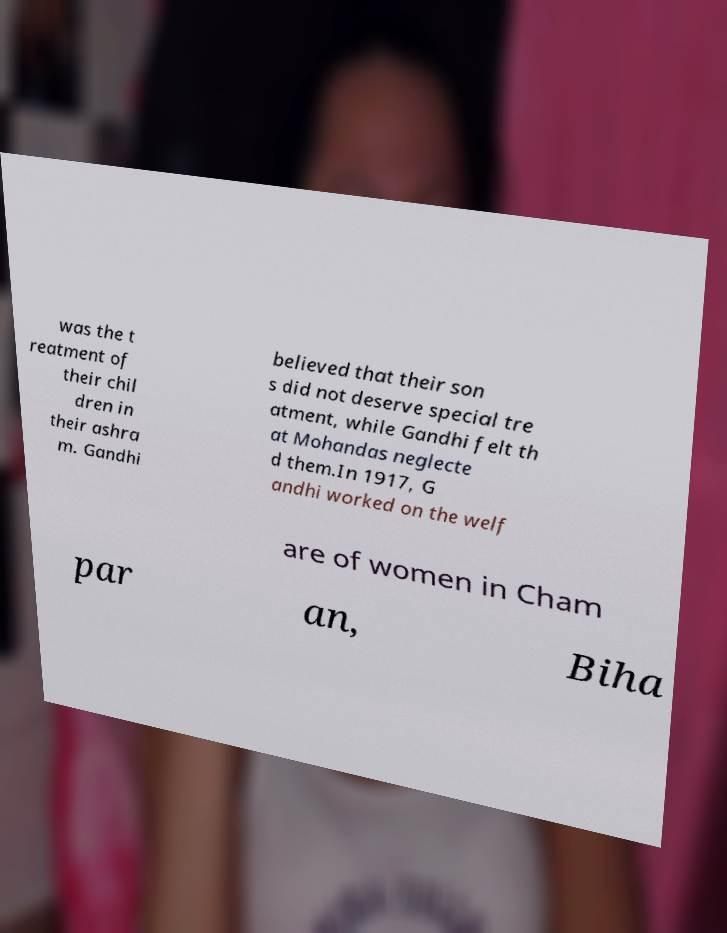I need the written content from this picture converted into text. Can you do that? was the t reatment of their chil dren in their ashra m. Gandhi believed that their son s did not deserve special tre atment, while Gandhi felt th at Mohandas neglecte d them.In 1917, G andhi worked on the welf are of women in Cham par an, Biha 